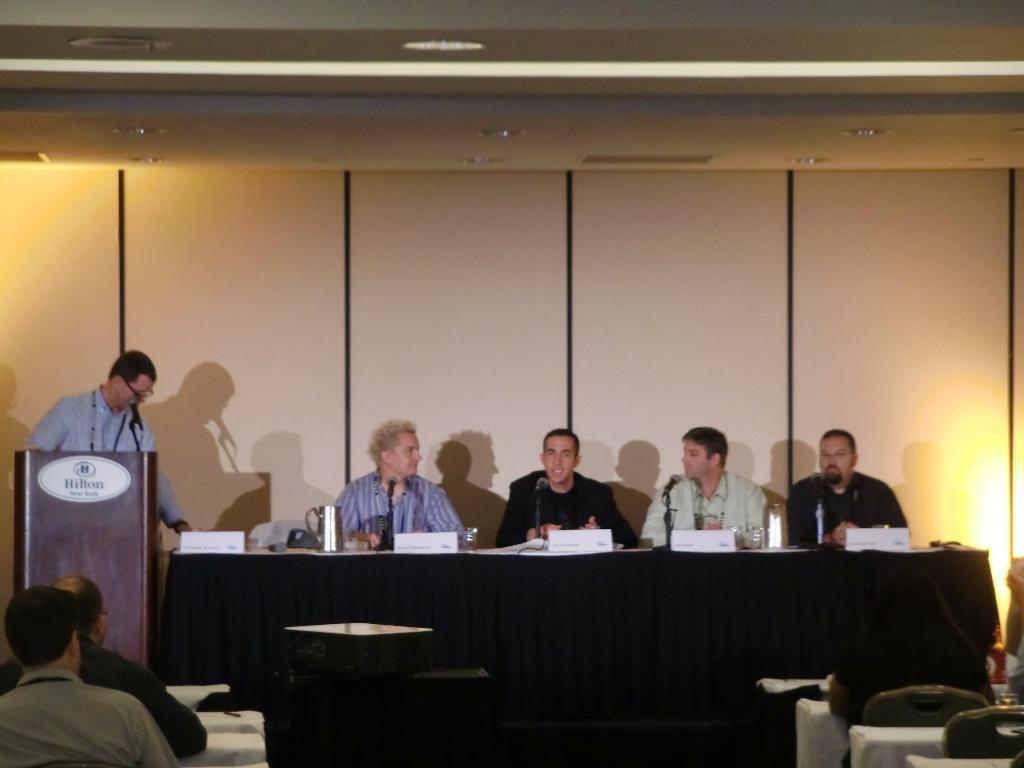Describe this image in one or two sentences. This is picture in a seminar hall, there are four people siting on a chair and this is a table covered with black cloth this a podium, backside of the podium there is man and on the podium there is a microphone. Background of the persons there is a wall with white color. There are chairs, on the chairs on the chairs there are persons siting and the watching the persons who are giving the seminar on the stage. This is projector. On the roof there is a light. 